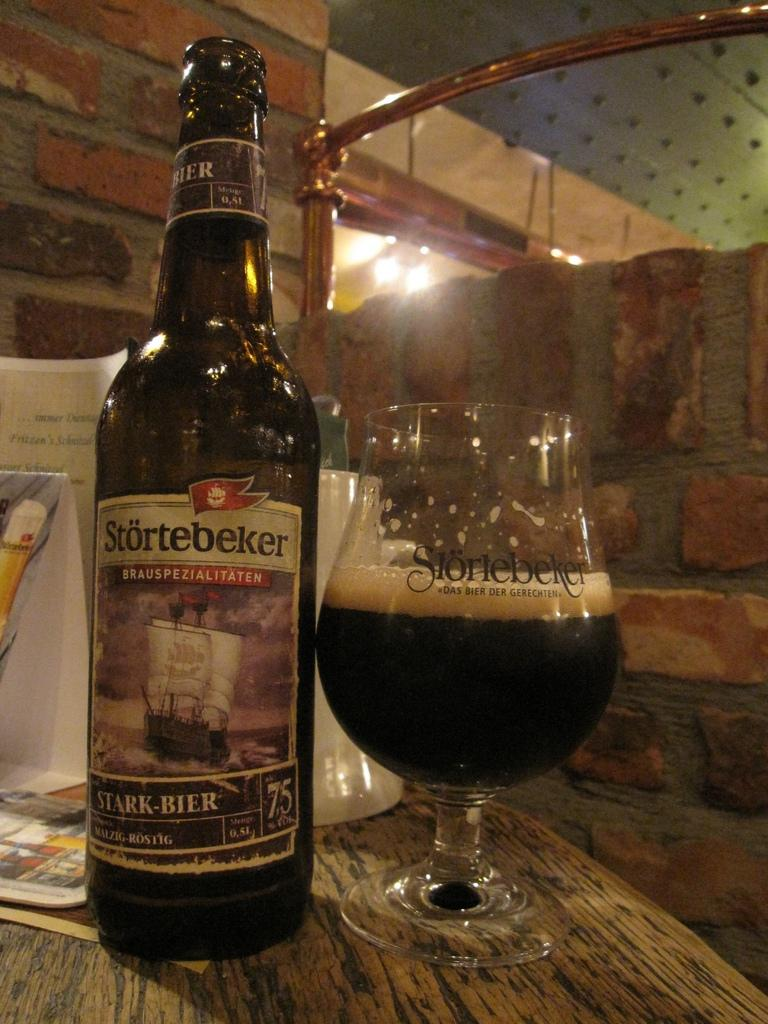<image>
Provide a brief description of the given image. a stortebeker bottle that is next to a glass 